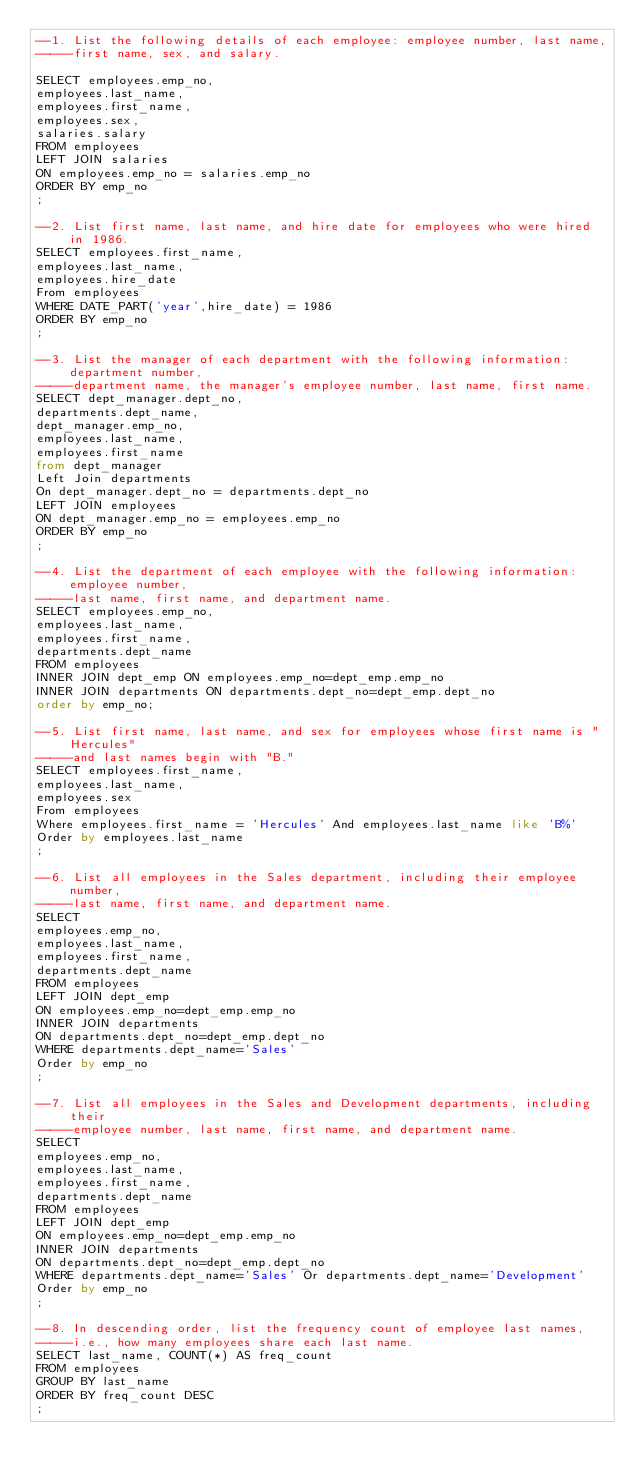<code> <loc_0><loc_0><loc_500><loc_500><_SQL_>--1. List the following details of each employee: employee number, last name, 
-----first name, sex, and salary.

SELECT employees.emp_no, 
employees.last_name,
employees.first_name,
employees.sex,
salaries.salary
FROM employees
LEFT JOIN salaries
ON employees.emp_no = salaries.emp_no
ORDER BY emp_no
;

--2. List first name, last name, and hire date for employees who were hired in 1986.
SELECT employees.first_name,
employees.last_name,
employees.hire_date
From employees
WHERE DATE_PART('year',hire_date) = 1986
ORDER BY emp_no
;

--3. List the manager of each department with the following information: department number, 
-----department name, the manager's employee number, last name, first name.
SELECT dept_manager.dept_no,
departments.dept_name,
dept_manager.emp_no,
employees.last_name,
employees.first_name
from dept_manager
Left Join departments
On dept_manager.dept_no = departments.dept_no
LEFT JOIN employees 
ON dept_manager.emp_no = employees.emp_no
ORDER BY emp_no
;

--4. List the department of each employee with the following information: employee number, 
-----last name, first name, and department name.
SELECT employees.emp_no,
employees.last_name,
employees.first_name,
departments.dept_name
FROM employees 
INNER JOIN dept_emp ON employees.emp_no=dept_emp.emp_no
INNER JOIN departments ON departments.dept_no=dept_emp.dept_no
order by emp_no;

--5. List first name, last name, and sex for employees whose first name is "Hercules" 
-----and last names begin with "B."
SELECT employees.first_name,
employees.last_name,
employees.sex
From employees
Where employees.first_name = 'Hercules' And employees.last_name like 'B%'
Order by employees.last_name
;

--6. List all employees in the Sales department, including their employee number, 
-----last name, first name, and department name.
SELECT 
employees.emp_no, 
employees.last_name, 
employees.first_name,
departments.dept_name
FROM employees 
LEFT JOIN dept_emp 
ON employees.emp_no=dept_emp.emp_no
INNER JOIN departments 
ON departments.dept_no=dept_emp.dept_no
WHERE departments.dept_name='Sales'
Order by emp_no
;

--7. List all employees in the Sales and Development departments, including their 
-----employee number, last name, first name, and department name.
SELECT 
employees.emp_no, 
employees.last_name, 
employees.first_name,
departments.dept_name
FROM employees 
LEFT JOIN dept_emp 
ON employees.emp_no=dept_emp.emp_no
INNER JOIN departments 
ON departments.dept_no=dept_emp.dept_no
WHERE departments.dept_name='Sales' Or departments.dept_name='Development' 
Order by emp_no
;

--8. In descending order, list the frequency count of employee last names, 
-----i.e., how many employees share each last name.
SELECT last_name, COUNT(*) AS freq_count
FROM employees
GROUP BY last_name
ORDER BY freq_count DESC
;





</code> 